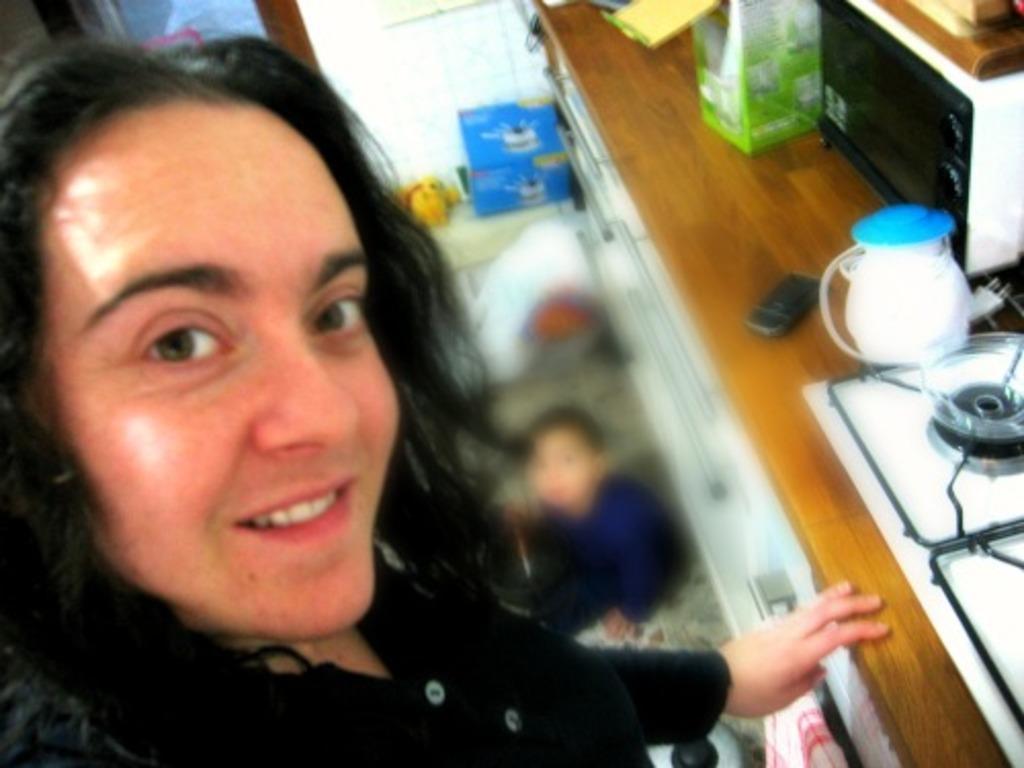Please provide a concise description of this image. In this image I can see a person taking a picture and there are stove,mobile,oven and some other objects on the desk. And there is a child on the floor. 